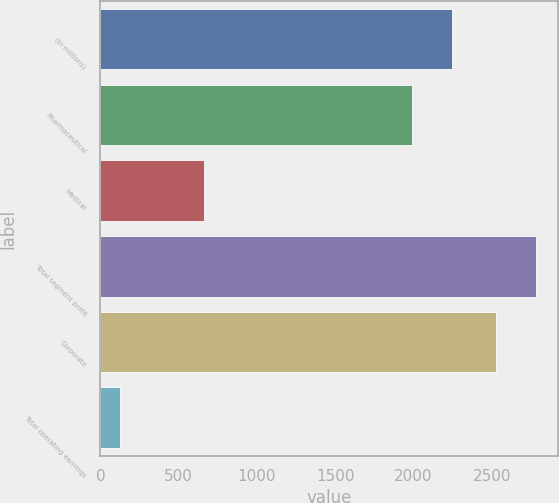Convert chart. <chart><loc_0><loc_0><loc_500><loc_500><bar_chart><fcel>(in millions)<fcel>Pharmaceutical<fcel>Medical<fcel>Total segment profit<fcel>Corporate<fcel>Total operating earnings<nl><fcel>2244.8<fcel>1992<fcel>662<fcel>2780.8<fcel>2528<fcel>126<nl></chart> 